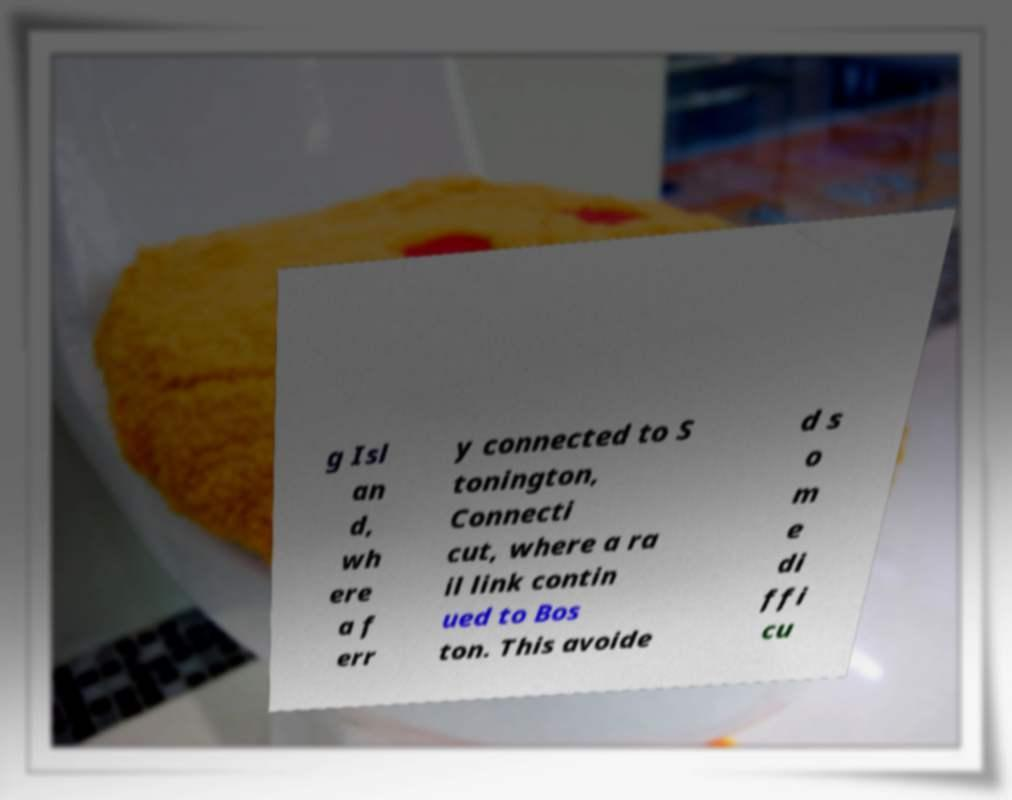Could you assist in decoding the text presented in this image and type it out clearly? g Isl an d, wh ere a f err y connected to S tonington, Connecti cut, where a ra il link contin ued to Bos ton. This avoide d s o m e di ffi cu 